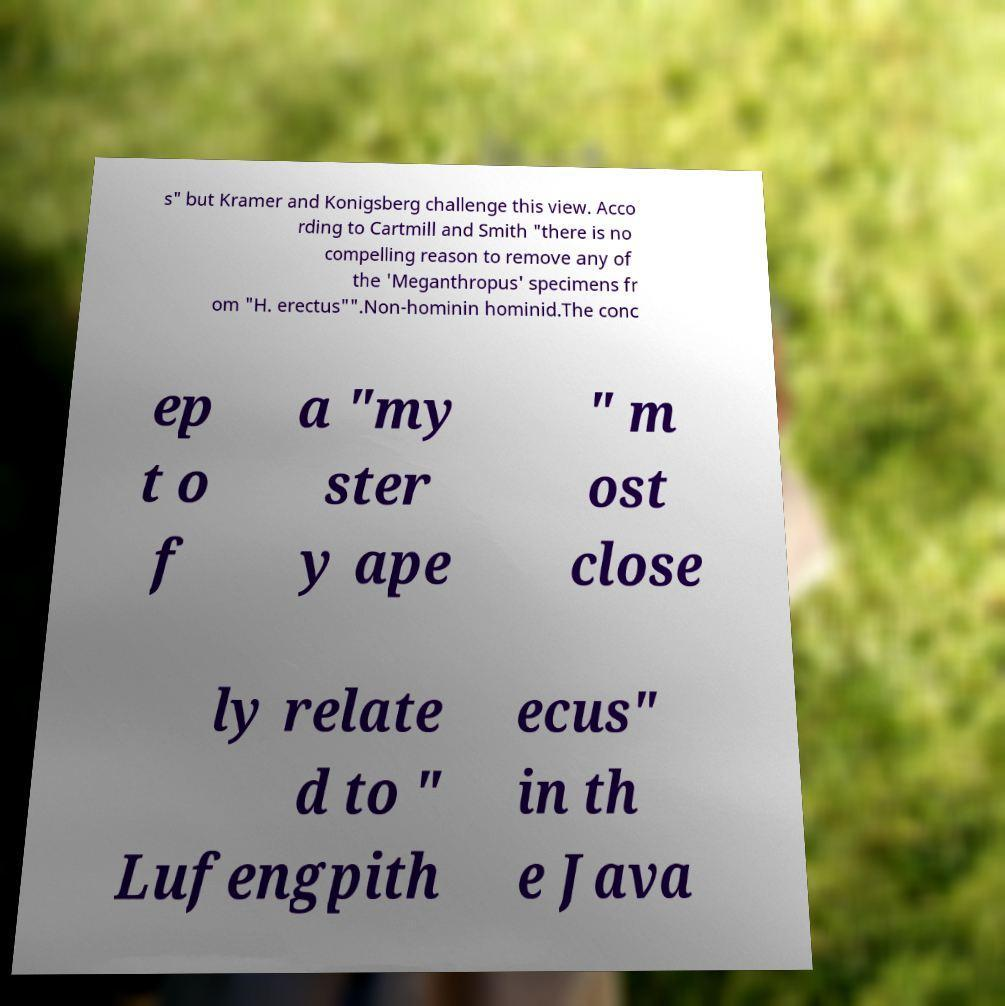Please identify and transcribe the text found in this image. s" but Kramer and Konigsberg challenge this view. Acco rding to Cartmill and Smith "there is no compelling reason to remove any of the 'Meganthropus' specimens fr om "H. erectus"".Non-hominin hominid.The conc ep t o f a "my ster y ape " m ost close ly relate d to " Lufengpith ecus" in th e Java 